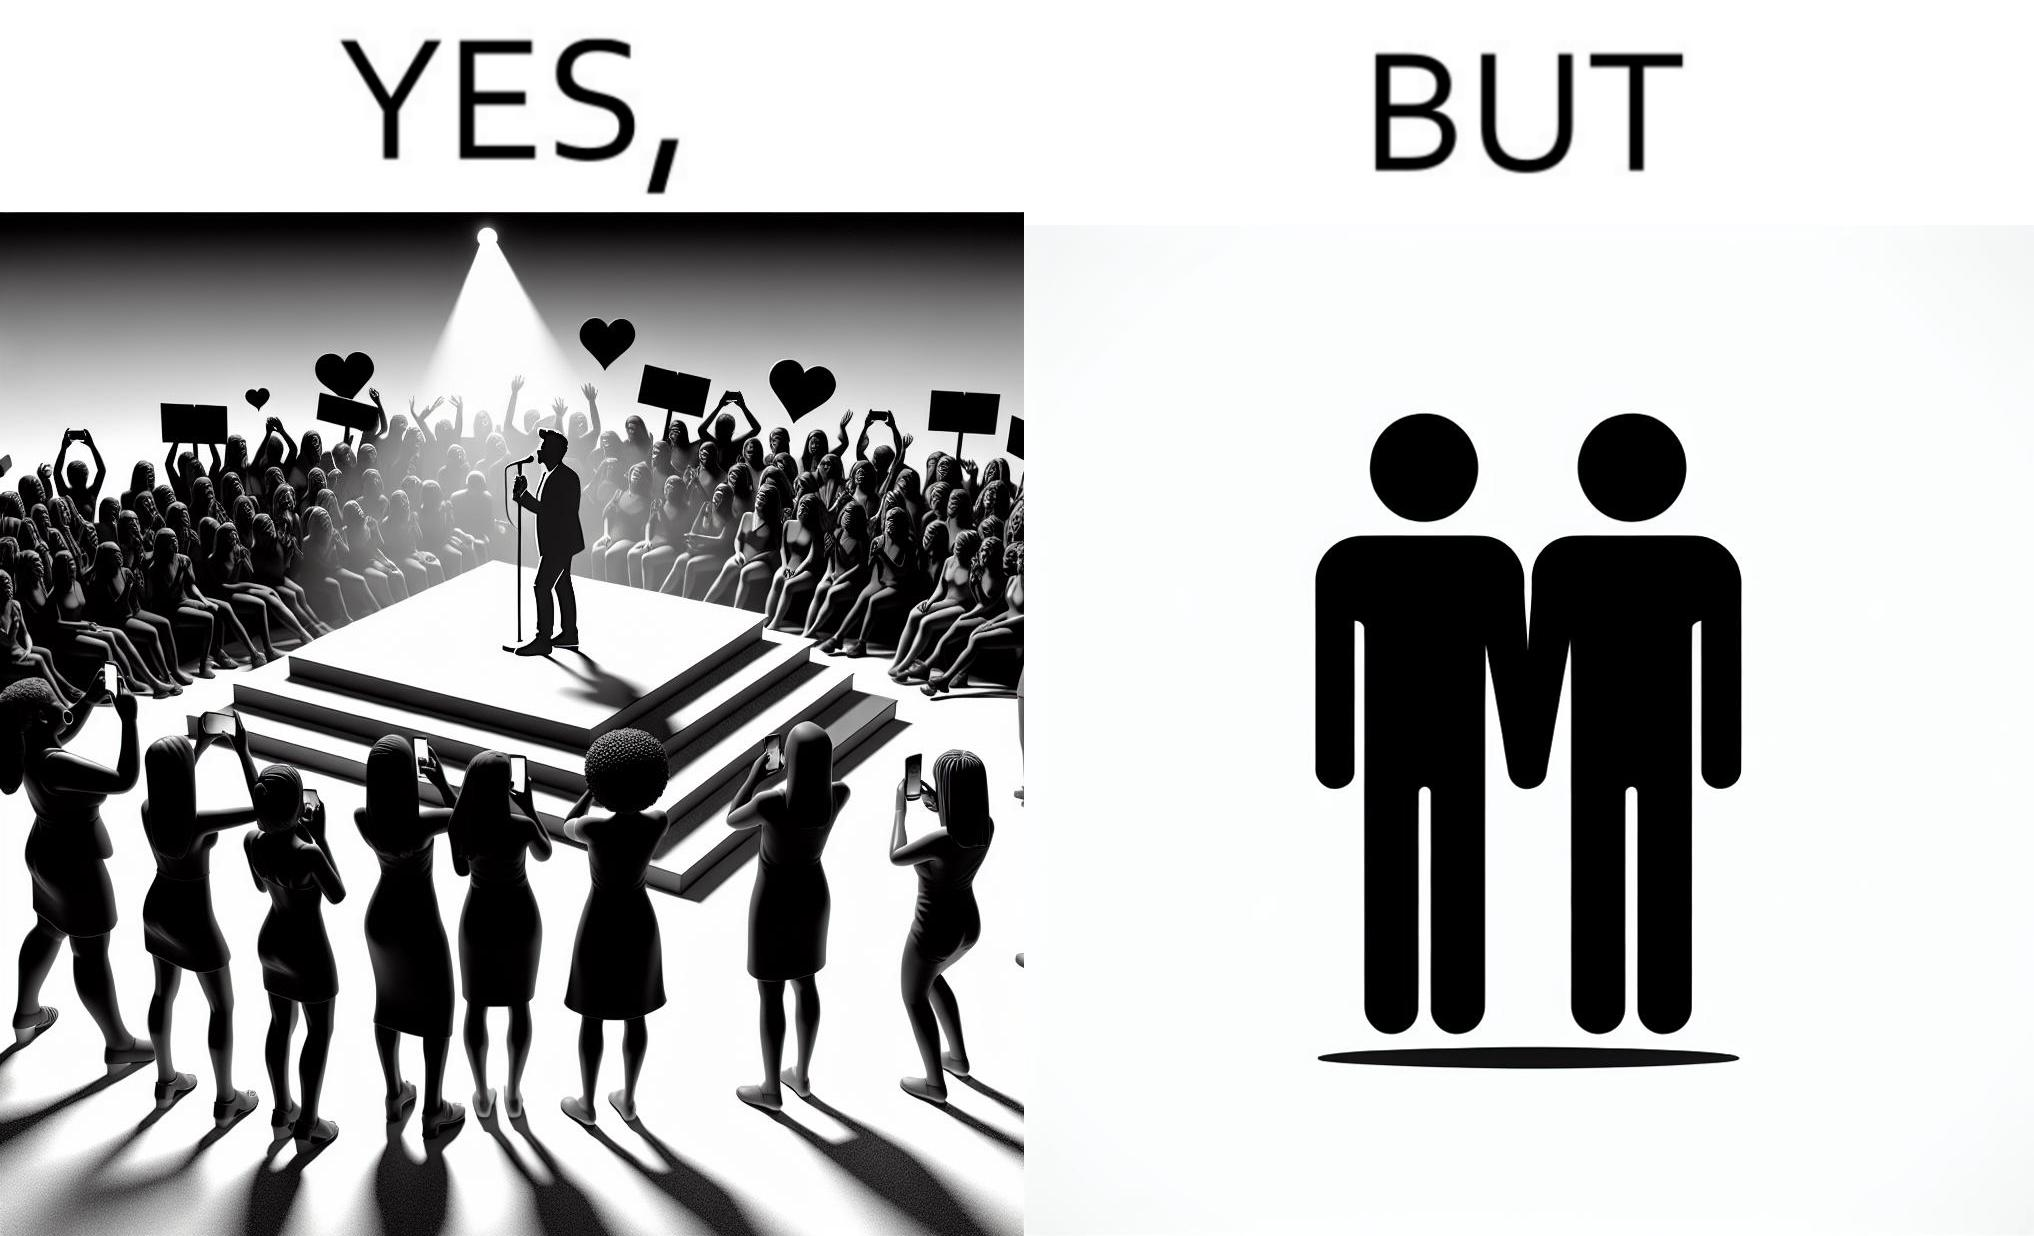What makes this image funny or satirical? The image is funny because while the girls loves the man, he likes other men instead of women. 